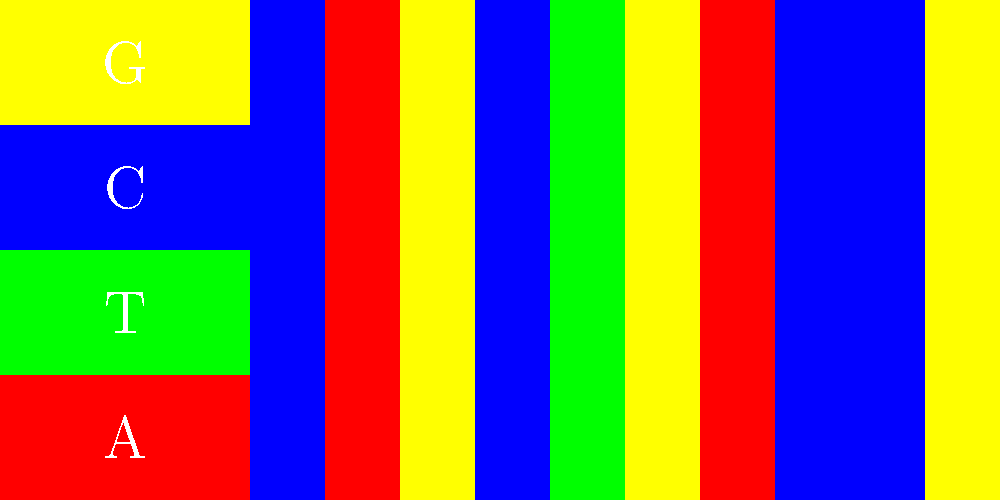Given the color-coded representation of DNA nucleotides (A=red, T=green, C=blue, G=yellow), identify the most frequent nucleotide in the sequence shown. What genetic trait might be associated with a high frequency of this nucleotide? 1. Observe the color legend:
   - A (Adenine) = Red
   - T (Thymine) = Green
   - C (Cytosine) = Blue
   - G (Guanine) = Yellow

2. Count the frequency of each color in the sequence:
   - Red (A): 4 occurrences
   - Green (T): 2 occurrences
   - Blue (C): 1 occurrence
   - Yellow (G): 3 occurrences

3. Identify the most frequent nucleotide:
   Adenine (A) appears most frequently with 4 occurrences.

4. Consider genetic traits associated with high adenine content:
   A high frequency of adenine in certain regions of DNA can be associated with increased gene expression. In some cases, this might be linked to traits such as:
   
   - Enhanced cognitive abilities: Some studies suggest that adenine-rich regions in genes related to brain function might be associated with improved memory or learning capacity.
   
   - Increased metabolism: Certain adenine-rich sequences in mitochondrial DNA have been linked to more efficient energy production, potentially affecting overall metabolism.

5. It's important to note that the relationship between nucleotide frequency and genetic traits is complex and often involves multiple factors. This simplified association is for illustrative purposes and should not be considered definitive.
Answer: Adenine (A); potentially enhanced cognitive abilities or increased metabolism 